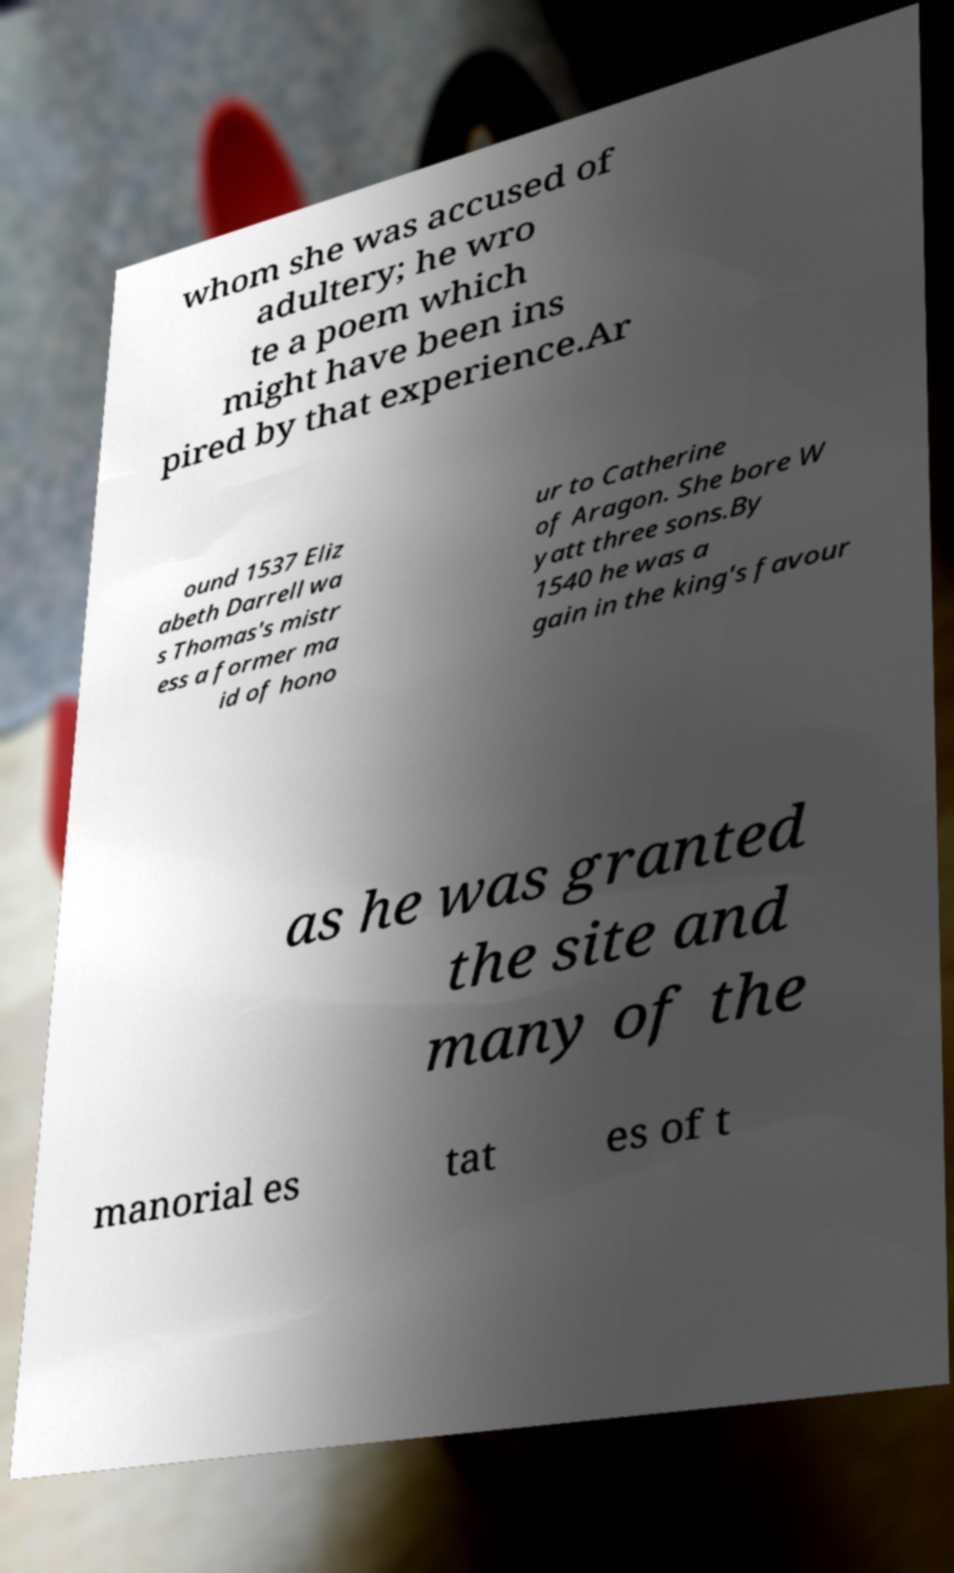There's text embedded in this image that I need extracted. Can you transcribe it verbatim? whom she was accused of adultery; he wro te a poem which might have been ins pired by that experience.Ar ound 1537 Eliz abeth Darrell wa s Thomas's mistr ess a former ma id of hono ur to Catherine of Aragon. She bore W yatt three sons.By 1540 he was a gain in the king's favour as he was granted the site and many of the manorial es tat es of t 